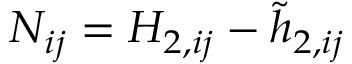<formula> <loc_0><loc_0><loc_500><loc_500>N _ { i j } = H _ { 2 , i j } - \tilde { h } _ { 2 , i j }</formula> 